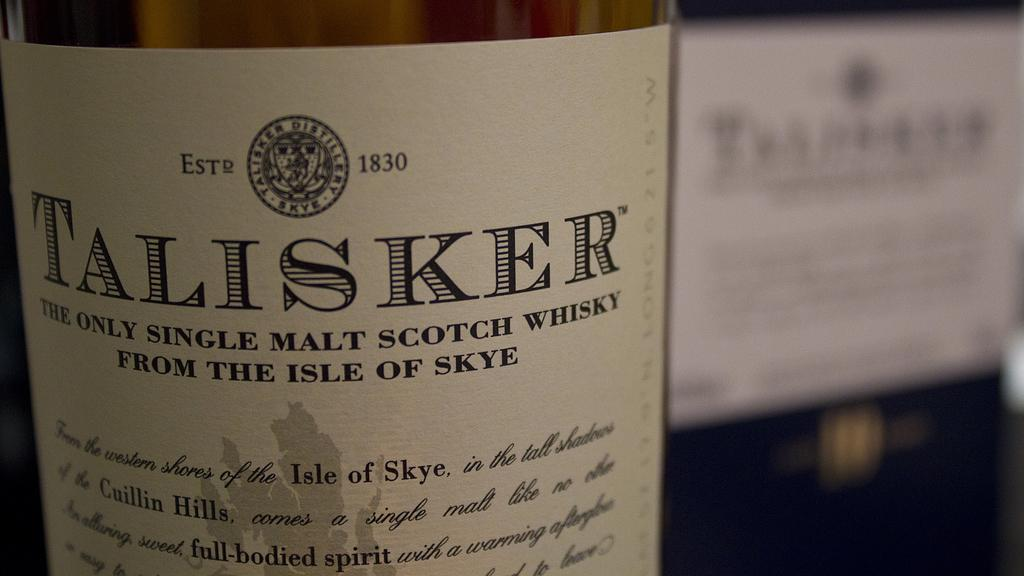Provide a one-sentence caption for the provided image. A bottle of single malt scotch whisky came from the Isle of Skye. 